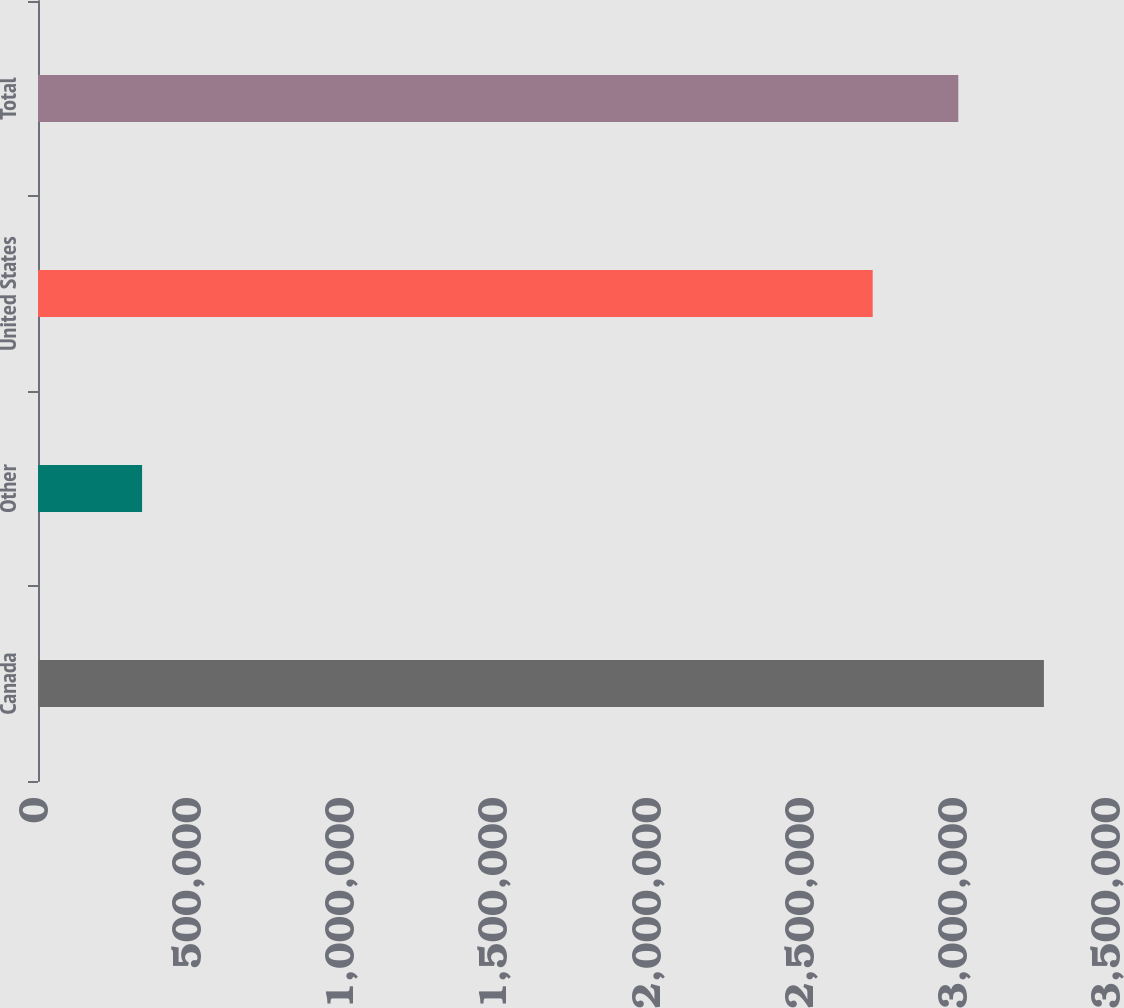Convert chart. <chart><loc_0><loc_0><loc_500><loc_500><bar_chart><fcel>Canada<fcel>Other<fcel>United States<fcel>Total<nl><fcel>3.28423e+06<fcel>339856<fcel>2.7252e+06<fcel>3.00471e+06<nl></chart> 